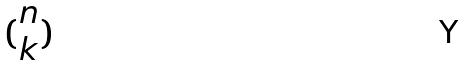Convert formula to latex. <formula><loc_0><loc_0><loc_500><loc_500>( \begin{matrix} n \\ k \end{matrix} )</formula> 